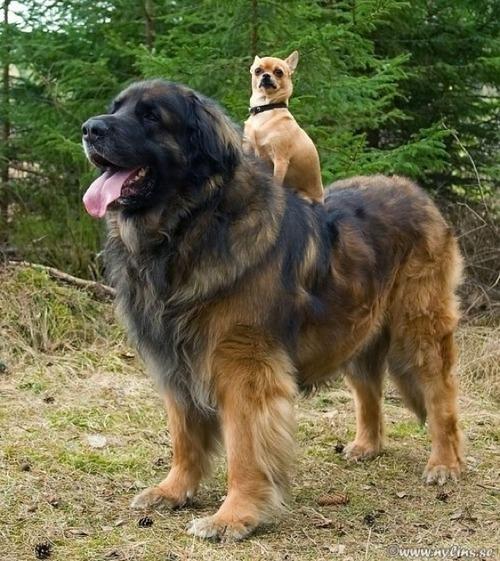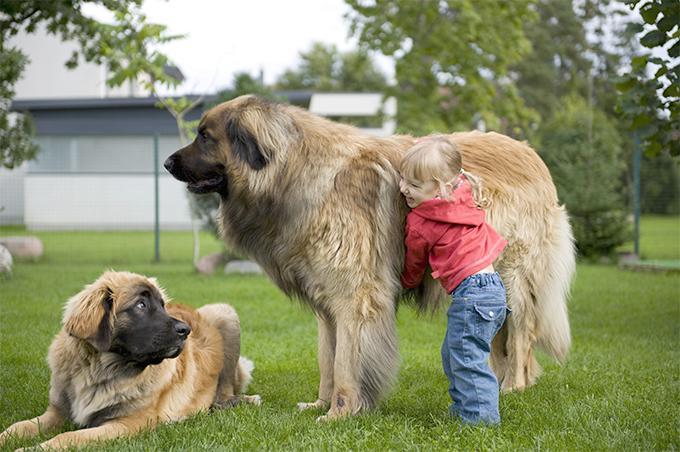The first image is the image on the left, the second image is the image on the right. For the images displayed, is the sentence "there is a human standing with a dog." factually correct? Answer yes or no. Yes. 